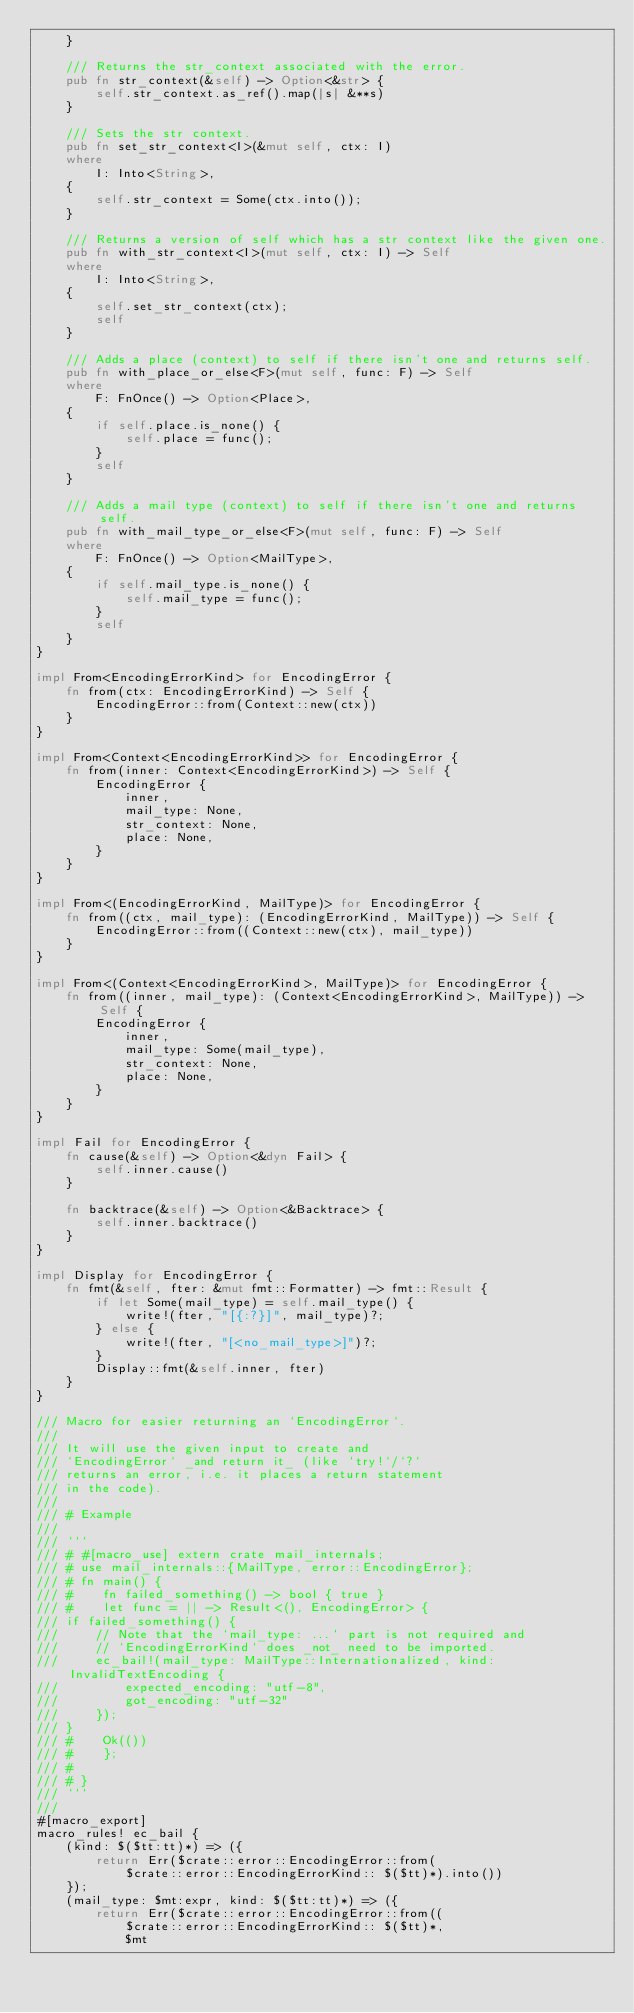<code> <loc_0><loc_0><loc_500><loc_500><_Rust_>    }

    /// Returns the str_context associated with the error.
    pub fn str_context(&self) -> Option<&str> {
        self.str_context.as_ref().map(|s| &**s)
    }

    /// Sets the str context.
    pub fn set_str_context<I>(&mut self, ctx: I)
    where
        I: Into<String>,
    {
        self.str_context = Some(ctx.into());
    }

    /// Returns a version of self which has a str context like the given one.
    pub fn with_str_context<I>(mut self, ctx: I) -> Self
    where
        I: Into<String>,
    {
        self.set_str_context(ctx);
        self
    }

    /// Adds a place (context) to self if there isn't one and returns self.
    pub fn with_place_or_else<F>(mut self, func: F) -> Self
    where
        F: FnOnce() -> Option<Place>,
    {
        if self.place.is_none() {
            self.place = func();
        }
        self
    }

    /// Adds a mail type (context) to self if there isn't one and returns self.
    pub fn with_mail_type_or_else<F>(mut self, func: F) -> Self
    where
        F: FnOnce() -> Option<MailType>,
    {
        if self.mail_type.is_none() {
            self.mail_type = func();
        }
        self
    }
}

impl From<EncodingErrorKind> for EncodingError {
    fn from(ctx: EncodingErrorKind) -> Self {
        EncodingError::from(Context::new(ctx))
    }
}

impl From<Context<EncodingErrorKind>> for EncodingError {
    fn from(inner: Context<EncodingErrorKind>) -> Self {
        EncodingError {
            inner,
            mail_type: None,
            str_context: None,
            place: None,
        }
    }
}

impl From<(EncodingErrorKind, MailType)> for EncodingError {
    fn from((ctx, mail_type): (EncodingErrorKind, MailType)) -> Self {
        EncodingError::from((Context::new(ctx), mail_type))
    }
}

impl From<(Context<EncodingErrorKind>, MailType)> for EncodingError {
    fn from((inner, mail_type): (Context<EncodingErrorKind>, MailType)) -> Self {
        EncodingError {
            inner,
            mail_type: Some(mail_type),
            str_context: None,
            place: None,
        }
    }
}

impl Fail for EncodingError {
    fn cause(&self) -> Option<&dyn Fail> {
        self.inner.cause()
    }

    fn backtrace(&self) -> Option<&Backtrace> {
        self.inner.backtrace()
    }
}

impl Display for EncodingError {
    fn fmt(&self, fter: &mut fmt::Formatter) -> fmt::Result {
        if let Some(mail_type) = self.mail_type() {
            write!(fter, "[{:?}]", mail_type)?;
        } else {
            write!(fter, "[<no_mail_type>]")?;
        }
        Display::fmt(&self.inner, fter)
    }
}

/// Macro for easier returning an `EncodingError`.
///
/// It will use the given input to create and
/// `EncodingError` _and return it_ (like `try!`/`?`
/// returns an error, i.e. it places a return statement
/// in the code).
///
/// # Example
///
/// ```
/// # #[macro_use] extern crate mail_internals;
/// # use mail_internals::{MailType, error::EncodingError};
/// # fn main() {
/// #    fn failed_something() -> bool { true }
/// #    let func = || -> Result<(), EncodingError> {
/// if failed_something() {
///     // Note that the `mail_type: ...` part is not required and
///     // `EncodingErrorKind` does _not_ need to be imported.
///     ec_bail!(mail_type: MailType::Internationalized, kind: InvalidTextEncoding {
///         expected_encoding: "utf-8",
///         got_encoding: "utf-32"
///     });
/// }
/// #    Ok(())
/// #    };
/// #
/// # }
/// ```
///
#[macro_export]
macro_rules! ec_bail {
    (kind: $($tt:tt)*) => ({
        return Err($crate::error::EncodingError::from(
            $crate::error::EncodingErrorKind:: $($tt)*).into())
    });
    (mail_type: $mt:expr, kind: $($tt:tt)*) => ({
        return Err($crate::error::EncodingError::from((
            $crate::error::EncodingErrorKind:: $($tt)*,
            $mt</code> 